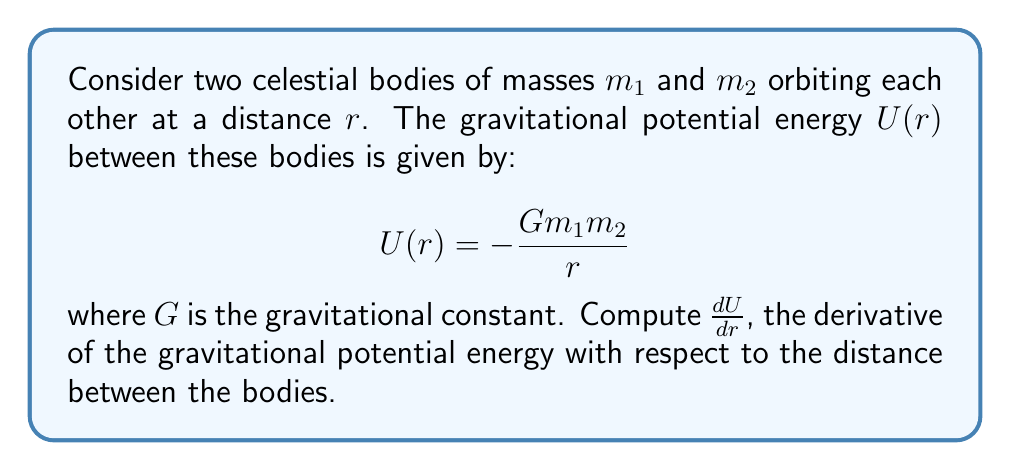Could you help me with this problem? To find $\frac{dU}{dr}$, we need to apply the power rule of differentiation:

1) First, let's rewrite the equation in a more convenient form:
   $$U(r) = -Gm_1m_2 \cdot r^{-1}$$

2) Now, we can apply the power rule. The derivative of $r^n$ with respect to $r$ is $n \cdot r^{n-1}$. In our case, $n = -1$:
   $$\frac{d}{dr}(r^{-1}) = -1 \cdot r^{-2} = -r^{-2}$$

3) We also need to consider the constant term $-Gm_1m_2$. The derivative of a constant is 0, but it will be multiplied by our result from step 2:
   $$\frac{dU}{dr} = -Gm_1m_2 \cdot \frac{d}{dr}(r^{-1}) = -Gm_1m_2 \cdot (-r^{-2})$$

4) Simplify:
   $$\frac{dU}{dr} = \frac{Gm_1m_2}{r^2}$$

This result represents the gravitational force between the two bodies, which is consistent with Newton's law of universal gravitation.
Answer: $$\frac{dU}{dr} = \frac{Gm_1m_2}{r^2}$$ 